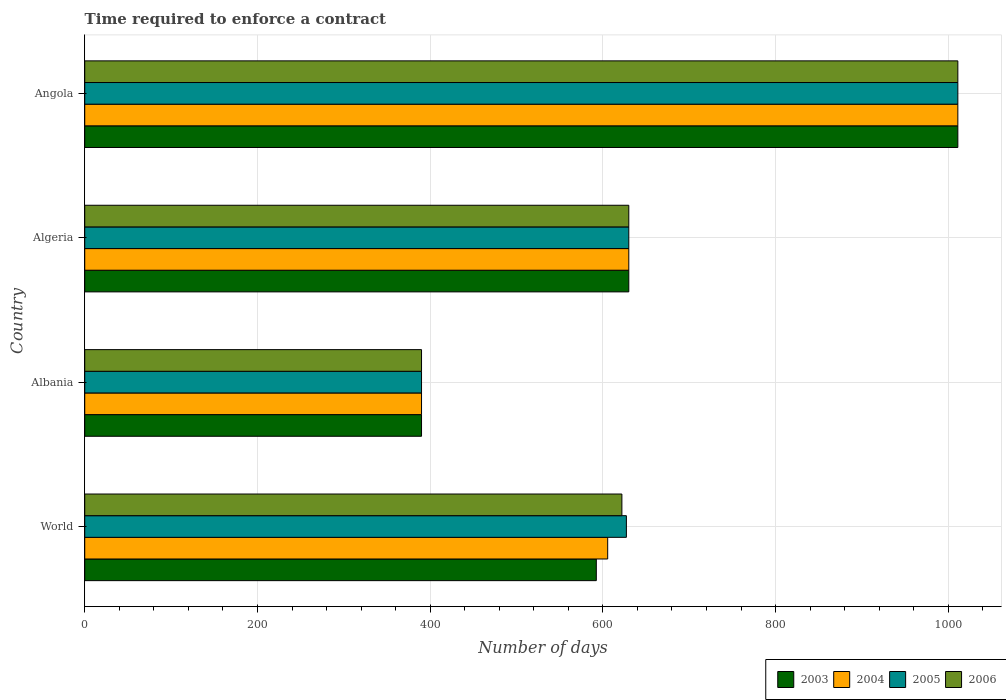How many different coloured bars are there?
Offer a terse response. 4. How many groups of bars are there?
Your answer should be very brief. 4. Are the number of bars per tick equal to the number of legend labels?
Offer a terse response. Yes. Are the number of bars on each tick of the Y-axis equal?
Provide a succinct answer. Yes. How many bars are there on the 1st tick from the top?
Give a very brief answer. 4. How many bars are there on the 3rd tick from the bottom?
Provide a short and direct response. 4. What is the label of the 3rd group of bars from the top?
Make the answer very short. Albania. In how many cases, is the number of bars for a given country not equal to the number of legend labels?
Ensure brevity in your answer.  0. What is the number of days required to enforce a contract in 2006 in Angola?
Your response must be concise. 1011. Across all countries, what is the maximum number of days required to enforce a contract in 2005?
Offer a very short reply. 1011. Across all countries, what is the minimum number of days required to enforce a contract in 2004?
Your answer should be very brief. 390. In which country was the number of days required to enforce a contract in 2006 maximum?
Keep it short and to the point. Angola. In which country was the number of days required to enforce a contract in 2005 minimum?
Make the answer very short. Albania. What is the total number of days required to enforce a contract in 2004 in the graph?
Offer a terse response. 2636.55. What is the difference between the number of days required to enforce a contract in 2004 in Albania and that in World?
Provide a succinct answer. -215.55. What is the difference between the number of days required to enforce a contract in 2006 in Albania and the number of days required to enforce a contract in 2005 in World?
Offer a very short reply. -237.21. What is the average number of days required to enforce a contract in 2004 per country?
Provide a short and direct response. 659.14. What is the difference between the number of days required to enforce a contract in 2005 and number of days required to enforce a contract in 2004 in Angola?
Offer a terse response. 0. What is the ratio of the number of days required to enforce a contract in 2004 in Albania to that in World?
Your answer should be compact. 0.64. What is the difference between the highest and the second highest number of days required to enforce a contract in 2005?
Provide a short and direct response. 381. What is the difference between the highest and the lowest number of days required to enforce a contract in 2005?
Keep it short and to the point. 621. Is the sum of the number of days required to enforce a contract in 2004 in Algeria and World greater than the maximum number of days required to enforce a contract in 2005 across all countries?
Give a very brief answer. Yes. What does the 4th bar from the top in Angola represents?
Provide a short and direct response. 2003. What does the 1st bar from the bottom in World represents?
Offer a terse response. 2003. How many bars are there?
Offer a very short reply. 16. How many countries are there in the graph?
Your response must be concise. 4. What is the difference between two consecutive major ticks on the X-axis?
Ensure brevity in your answer.  200. Are the values on the major ticks of X-axis written in scientific E-notation?
Your response must be concise. No. Does the graph contain any zero values?
Give a very brief answer. No. Does the graph contain grids?
Your answer should be very brief. Yes. Where does the legend appear in the graph?
Offer a very short reply. Bottom right. How many legend labels are there?
Provide a short and direct response. 4. How are the legend labels stacked?
Provide a short and direct response. Horizontal. What is the title of the graph?
Your answer should be compact. Time required to enforce a contract. Does "1976" appear as one of the legend labels in the graph?
Provide a succinct answer. No. What is the label or title of the X-axis?
Provide a succinct answer. Number of days. What is the label or title of the Y-axis?
Ensure brevity in your answer.  Country. What is the Number of days of 2003 in World?
Your answer should be very brief. 592.38. What is the Number of days in 2004 in World?
Offer a very short reply. 605.55. What is the Number of days of 2005 in World?
Give a very brief answer. 627.21. What is the Number of days in 2006 in World?
Keep it short and to the point. 621.99. What is the Number of days in 2003 in Albania?
Make the answer very short. 390. What is the Number of days in 2004 in Albania?
Offer a terse response. 390. What is the Number of days of 2005 in Albania?
Your response must be concise. 390. What is the Number of days in 2006 in Albania?
Ensure brevity in your answer.  390. What is the Number of days of 2003 in Algeria?
Offer a terse response. 630. What is the Number of days in 2004 in Algeria?
Provide a succinct answer. 630. What is the Number of days of 2005 in Algeria?
Give a very brief answer. 630. What is the Number of days of 2006 in Algeria?
Your answer should be compact. 630. What is the Number of days in 2003 in Angola?
Your answer should be compact. 1011. What is the Number of days in 2004 in Angola?
Your answer should be compact. 1011. What is the Number of days in 2005 in Angola?
Your answer should be very brief. 1011. What is the Number of days in 2006 in Angola?
Keep it short and to the point. 1011. Across all countries, what is the maximum Number of days in 2003?
Your response must be concise. 1011. Across all countries, what is the maximum Number of days of 2004?
Offer a very short reply. 1011. Across all countries, what is the maximum Number of days of 2005?
Provide a short and direct response. 1011. Across all countries, what is the maximum Number of days in 2006?
Your response must be concise. 1011. Across all countries, what is the minimum Number of days of 2003?
Give a very brief answer. 390. Across all countries, what is the minimum Number of days in 2004?
Your answer should be very brief. 390. Across all countries, what is the minimum Number of days of 2005?
Your answer should be compact. 390. Across all countries, what is the minimum Number of days of 2006?
Offer a terse response. 390. What is the total Number of days of 2003 in the graph?
Make the answer very short. 2623.38. What is the total Number of days in 2004 in the graph?
Your answer should be very brief. 2636.55. What is the total Number of days of 2005 in the graph?
Offer a very short reply. 2658.21. What is the total Number of days in 2006 in the graph?
Give a very brief answer. 2652.99. What is the difference between the Number of days in 2003 in World and that in Albania?
Your answer should be compact. 202.38. What is the difference between the Number of days in 2004 in World and that in Albania?
Offer a very short reply. 215.55. What is the difference between the Number of days of 2005 in World and that in Albania?
Provide a short and direct response. 237.21. What is the difference between the Number of days of 2006 in World and that in Albania?
Provide a succinct answer. 231.99. What is the difference between the Number of days of 2003 in World and that in Algeria?
Keep it short and to the point. -37.62. What is the difference between the Number of days in 2004 in World and that in Algeria?
Keep it short and to the point. -24.45. What is the difference between the Number of days of 2005 in World and that in Algeria?
Provide a short and direct response. -2.79. What is the difference between the Number of days of 2006 in World and that in Algeria?
Keep it short and to the point. -8.01. What is the difference between the Number of days of 2003 in World and that in Angola?
Keep it short and to the point. -418.62. What is the difference between the Number of days of 2004 in World and that in Angola?
Make the answer very short. -405.45. What is the difference between the Number of days in 2005 in World and that in Angola?
Keep it short and to the point. -383.79. What is the difference between the Number of days in 2006 in World and that in Angola?
Offer a very short reply. -389.01. What is the difference between the Number of days of 2003 in Albania and that in Algeria?
Make the answer very short. -240. What is the difference between the Number of days in 2004 in Albania and that in Algeria?
Your answer should be very brief. -240. What is the difference between the Number of days of 2005 in Albania and that in Algeria?
Provide a succinct answer. -240. What is the difference between the Number of days in 2006 in Albania and that in Algeria?
Your answer should be compact. -240. What is the difference between the Number of days of 2003 in Albania and that in Angola?
Provide a succinct answer. -621. What is the difference between the Number of days of 2004 in Albania and that in Angola?
Offer a terse response. -621. What is the difference between the Number of days of 2005 in Albania and that in Angola?
Your answer should be very brief. -621. What is the difference between the Number of days of 2006 in Albania and that in Angola?
Your answer should be compact. -621. What is the difference between the Number of days of 2003 in Algeria and that in Angola?
Give a very brief answer. -381. What is the difference between the Number of days of 2004 in Algeria and that in Angola?
Keep it short and to the point. -381. What is the difference between the Number of days in 2005 in Algeria and that in Angola?
Make the answer very short. -381. What is the difference between the Number of days of 2006 in Algeria and that in Angola?
Offer a terse response. -381. What is the difference between the Number of days of 2003 in World and the Number of days of 2004 in Albania?
Make the answer very short. 202.38. What is the difference between the Number of days in 2003 in World and the Number of days in 2005 in Albania?
Provide a short and direct response. 202.38. What is the difference between the Number of days in 2003 in World and the Number of days in 2006 in Albania?
Provide a succinct answer. 202.38. What is the difference between the Number of days of 2004 in World and the Number of days of 2005 in Albania?
Give a very brief answer. 215.55. What is the difference between the Number of days in 2004 in World and the Number of days in 2006 in Albania?
Your answer should be very brief. 215.55. What is the difference between the Number of days of 2005 in World and the Number of days of 2006 in Albania?
Keep it short and to the point. 237.21. What is the difference between the Number of days of 2003 in World and the Number of days of 2004 in Algeria?
Ensure brevity in your answer.  -37.62. What is the difference between the Number of days in 2003 in World and the Number of days in 2005 in Algeria?
Provide a succinct answer. -37.62. What is the difference between the Number of days in 2003 in World and the Number of days in 2006 in Algeria?
Make the answer very short. -37.62. What is the difference between the Number of days of 2004 in World and the Number of days of 2005 in Algeria?
Make the answer very short. -24.45. What is the difference between the Number of days in 2004 in World and the Number of days in 2006 in Algeria?
Your response must be concise. -24.45. What is the difference between the Number of days in 2005 in World and the Number of days in 2006 in Algeria?
Keep it short and to the point. -2.79. What is the difference between the Number of days of 2003 in World and the Number of days of 2004 in Angola?
Make the answer very short. -418.62. What is the difference between the Number of days in 2003 in World and the Number of days in 2005 in Angola?
Provide a short and direct response. -418.62. What is the difference between the Number of days in 2003 in World and the Number of days in 2006 in Angola?
Offer a terse response. -418.62. What is the difference between the Number of days in 2004 in World and the Number of days in 2005 in Angola?
Your answer should be compact. -405.45. What is the difference between the Number of days of 2004 in World and the Number of days of 2006 in Angola?
Your answer should be very brief. -405.45. What is the difference between the Number of days of 2005 in World and the Number of days of 2006 in Angola?
Keep it short and to the point. -383.79. What is the difference between the Number of days in 2003 in Albania and the Number of days in 2004 in Algeria?
Offer a very short reply. -240. What is the difference between the Number of days in 2003 in Albania and the Number of days in 2005 in Algeria?
Your response must be concise. -240. What is the difference between the Number of days in 2003 in Albania and the Number of days in 2006 in Algeria?
Keep it short and to the point. -240. What is the difference between the Number of days of 2004 in Albania and the Number of days of 2005 in Algeria?
Give a very brief answer. -240. What is the difference between the Number of days in 2004 in Albania and the Number of days in 2006 in Algeria?
Your answer should be compact. -240. What is the difference between the Number of days of 2005 in Albania and the Number of days of 2006 in Algeria?
Your answer should be compact. -240. What is the difference between the Number of days in 2003 in Albania and the Number of days in 2004 in Angola?
Offer a terse response. -621. What is the difference between the Number of days in 2003 in Albania and the Number of days in 2005 in Angola?
Give a very brief answer. -621. What is the difference between the Number of days in 2003 in Albania and the Number of days in 2006 in Angola?
Offer a very short reply. -621. What is the difference between the Number of days in 2004 in Albania and the Number of days in 2005 in Angola?
Your response must be concise. -621. What is the difference between the Number of days of 2004 in Albania and the Number of days of 2006 in Angola?
Make the answer very short. -621. What is the difference between the Number of days of 2005 in Albania and the Number of days of 2006 in Angola?
Make the answer very short. -621. What is the difference between the Number of days of 2003 in Algeria and the Number of days of 2004 in Angola?
Your response must be concise. -381. What is the difference between the Number of days in 2003 in Algeria and the Number of days in 2005 in Angola?
Keep it short and to the point. -381. What is the difference between the Number of days of 2003 in Algeria and the Number of days of 2006 in Angola?
Your answer should be compact. -381. What is the difference between the Number of days of 2004 in Algeria and the Number of days of 2005 in Angola?
Ensure brevity in your answer.  -381. What is the difference between the Number of days in 2004 in Algeria and the Number of days in 2006 in Angola?
Your answer should be very brief. -381. What is the difference between the Number of days in 2005 in Algeria and the Number of days in 2006 in Angola?
Your answer should be very brief. -381. What is the average Number of days of 2003 per country?
Offer a very short reply. 655.85. What is the average Number of days in 2004 per country?
Your answer should be very brief. 659.14. What is the average Number of days of 2005 per country?
Provide a succinct answer. 664.55. What is the average Number of days in 2006 per country?
Your response must be concise. 663.25. What is the difference between the Number of days in 2003 and Number of days in 2004 in World?
Keep it short and to the point. -13.17. What is the difference between the Number of days in 2003 and Number of days in 2005 in World?
Offer a terse response. -34.83. What is the difference between the Number of days of 2003 and Number of days of 2006 in World?
Give a very brief answer. -29.61. What is the difference between the Number of days in 2004 and Number of days in 2005 in World?
Your answer should be very brief. -21.67. What is the difference between the Number of days in 2004 and Number of days in 2006 in World?
Your answer should be very brief. -16.45. What is the difference between the Number of days in 2005 and Number of days in 2006 in World?
Provide a succinct answer. 5.22. What is the difference between the Number of days of 2003 and Number of days of 2004 in Albania?
Make the answer very short. 0. What is the difference between the Number of days in 2003 and Number of days in 2006 in Albania?
Your answer should be very brief. 0. What is the difference between the Number of days of 2005 and Number of days of 2006 in Albania?
Keep it short and to the point. 0. What is the difference between the Number of days of 2003 and Number of days of 2004 in Algeria?
Offer a very short reply. 0. What is the difference between the Number of days of 2003 and Number of days of 2005 in Algeria?
Make the answer very short. 0. What is the difference between the Number of days of 2003 and Number of days of 2006 in Algeria?
Offer a terse response. 0. What is the difference between the Number of days of 2004 and Number of days of 2005 in Algeria?
Provide a short and direct response. 0. What is the difference between the Number of days in 2004 and Number of days in 2006 in Algeria?
Your answer should be very brief. 0. What is the difference between the Number of days in 2003 and Number of days in 2005 in Angola?
Your response must be concise. 0. What is the difference between the Number of days of 2003 and Number of days of 2006 in Angola?
Ensure brevity in your answer.  0. What is the difference between the Number of days in 2004 and Number of days in 2005 in Angola?
Your answer should be compact. 0. What is the difference between the Number of days of 2004 and Number of days of 2006 in Angola?
Offer a terse response. 0. What is the difference between the Number of days of 2005 and Number of days of 2006 in Angola?
Keep it short and to the point. 0. What is the ratio of the Number of days of 2003 in World to that in Albania?
Provide a short and direct response. 1.52. What is the ratio of the Number of days in 2004 in World to that in Albania?
Ensure brevity in your answer.  1.55. What is the ratio of the Number of days in 2005 in World to that in Albania?
Provide a short and direct response. 1.61. What is the ratio of the Number of days in 2006 in World to that in Albania?
Keep it short and to the point. 1.59. What is the ratio of the Number of days of 2003 in World to that in Algeria?
Offer a very short reply. 0.94. What is the ratio of the Number of days in 2004 in World to that in Algeria?
Your answer should be very brief. 0.96. What is the ratio of the Number of days in 2005 in World to that in Algeria?
Give a very brief answer. 1. What is the ratio of the Number of days of 2006 in World to that in Algeria?
Offer a very short reply. 0.99. What is the ratio of the Number of days in 2003 in World to that in Angola?
Keep it short and to the point. 0.59. What is the ratio of the Number of days of 2004 in World to that in Angola?
Provide a succinct answer. 0.6. What is the ratio of the Number of days of 2005 in World to that in Angola?
Your answer should be very brief. 0.62. What is the ratio of the Number of days of 2006 in World to that in Angola?
Give a very brief answer. 0.62. What is the ratio of the Number of days in 2003 in Albania to that in Algeria?
Give a very brief answer. 0.62. What is the ratio of the Number of days in 2004 in Albania to that in Algeria?
Your answer should be compact. 0.62. What is the ratio of the Number of days of 2005 in Albania to that in Algeria?
Your answer should be compact. 0.62. What is the ratio of the Number of days of 2006 in Albania to that in Algeria?
Offer a terse response. 0.62. What is the ratio of the Number of days of 2003 in Albania to that in Angola?
Your answer should be very brief. 0.39. What is the ratio of the Number of days of 2004 in Albania to that in Angola?
Your response must be concise. 0.39. What is the ratio of the Number of days of 2005 in Albania to that in Angola?
Make the answer very short. 0.39. What is the ratio of the Number of days in 2006 in Albania to that in Angola?
Keep it short and to the point. 0.39. What is the ratio of the Number of days in 2003 in Algeria to that in Angola?
Provide a succinct answer. 0.62. What is the ratio of the Number of days in 2004 in Algeria to that in Angola?
Ensure brevity in your answer.  0.62. What is the ratio of the Number of days in 2005 in Algeria to that in Angola?
Your answer should be compact. 0.62. What is the ratio of the Number of days of 2006 in Algeria to that in Angola?
Keep it short and to the point. 0.62. What is the difference between the highest and the second highest Number of days of 2003?
Provide a succinct answer. 381. What is the difference between the highest and the second highest Number of days of 2004?
Keep it short and to the point. 381. What is the difference between the highest and the second highest Number of days of 2005?
Keep it short and to the point. 381. What is the difference between the highest and the second highest Number of days of 2006?
Offer a very short reply. 381. What is the difference between the highest and the lowest Number of days in 2003?
Make the answer very short. 621. What is the difference between the highest and the lowest Number of days in 2004?
Offer a very short reply. 621. What is the difference between the highest and the lowest Number of days in 2005?
Offer a very short reply. 621. What is the difference between the highest and the lowest Number of days in 2006?
Your response must be concise. 621. 